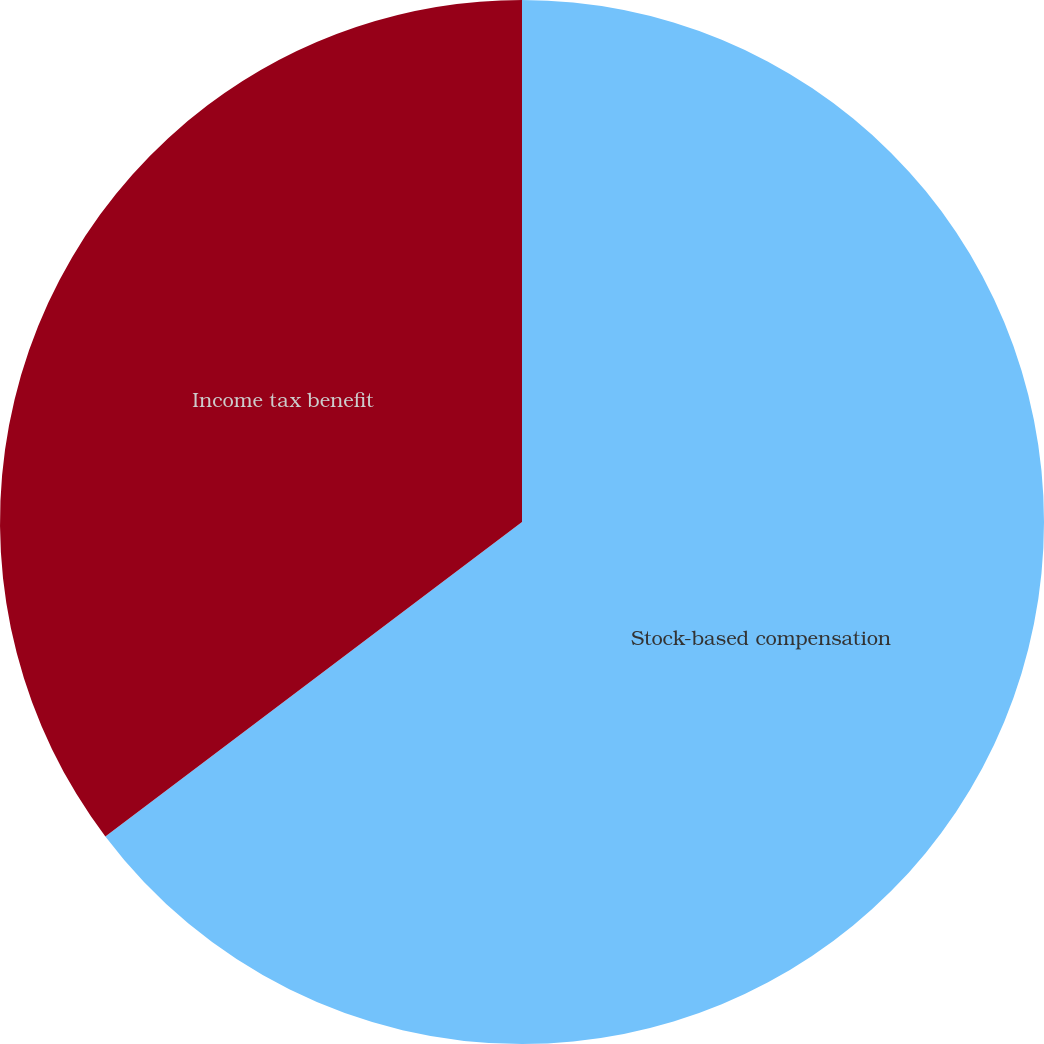<chart> <loc_0><loc_0><loc_500><loc_500><pie_chart><fcel>Stock-based compensation<fcel>Income tax benefit<nl><fcel>64.71%<fcel>35.29%<nl></chart> 